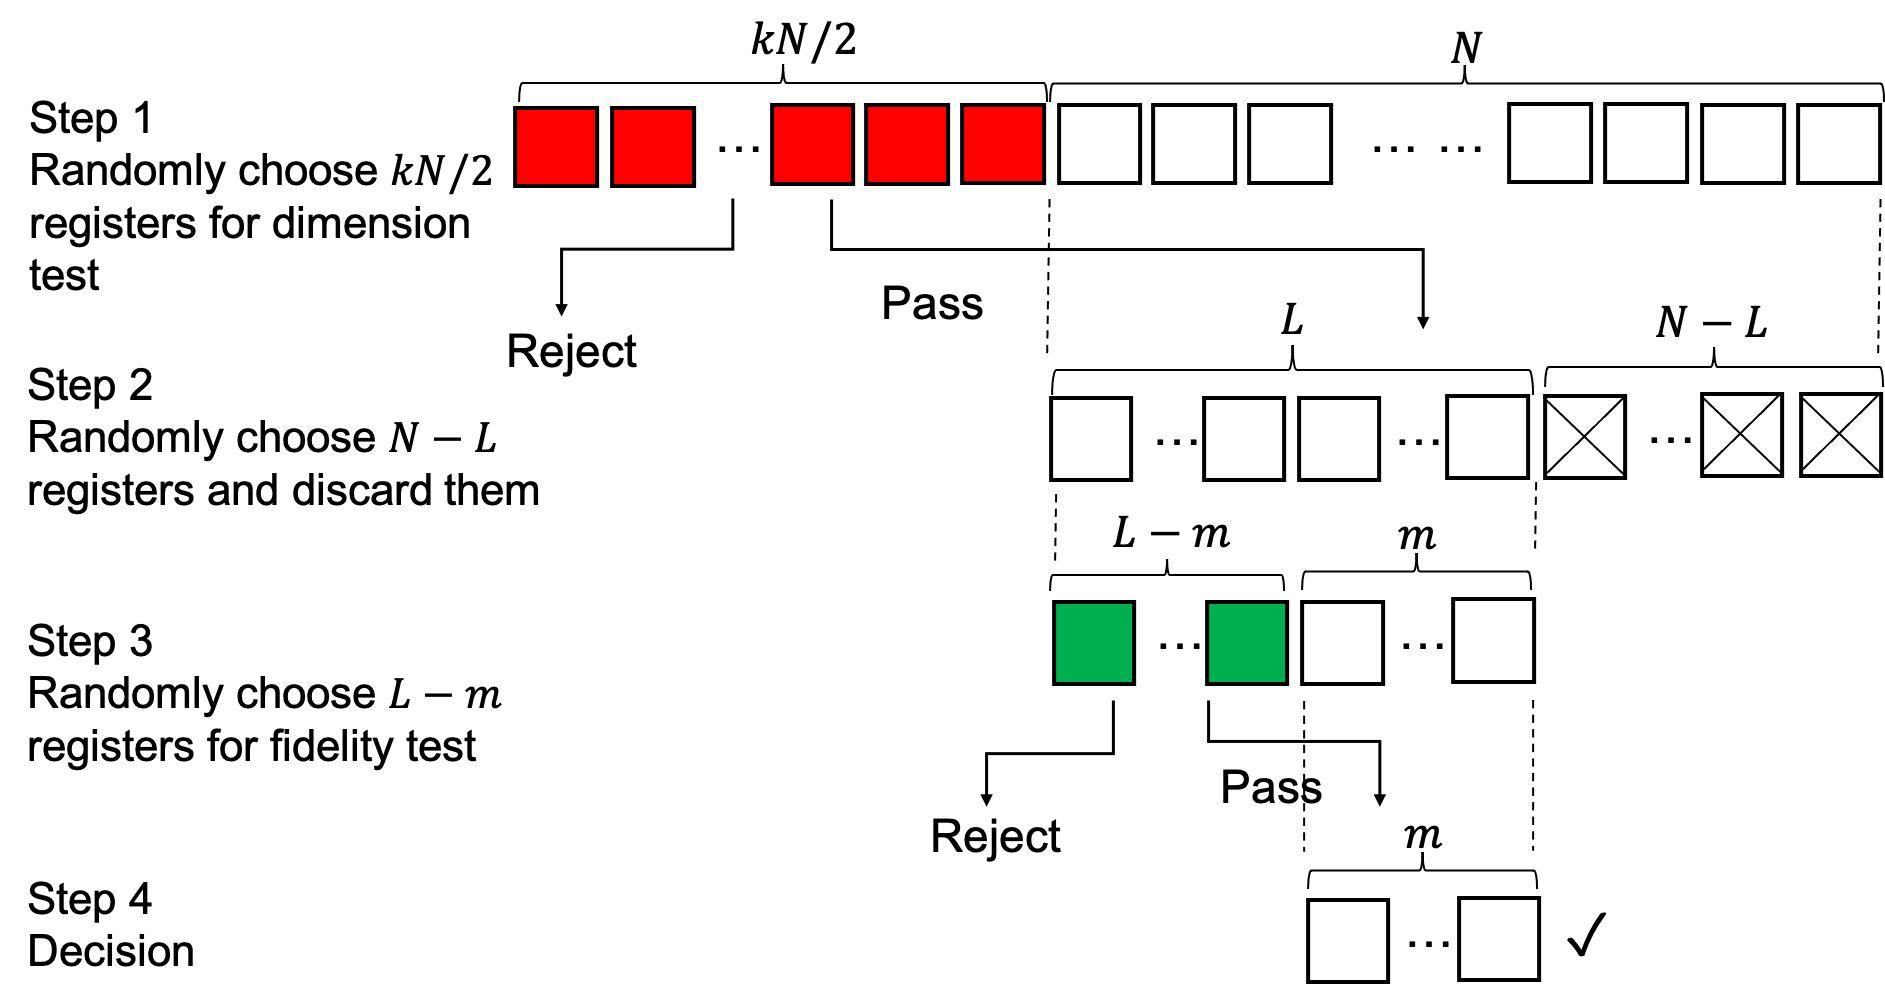According to the process depicted in the figure, what happens to the registers that do not pass the dimension test in Step 1? In the diagram, we observe an organized selection process where the registers undergo a dimension test in Step 1. Those that fail to meet the criteria are immediately rejected, meaning they are excluded from any further evaluation steps. The process is clearly designed to streamline the selection by swiftly eliminating unsuitable candidates, ensuring only those that pass the initial dimension test can proceed to subsequent scrutiny in Step 2. 